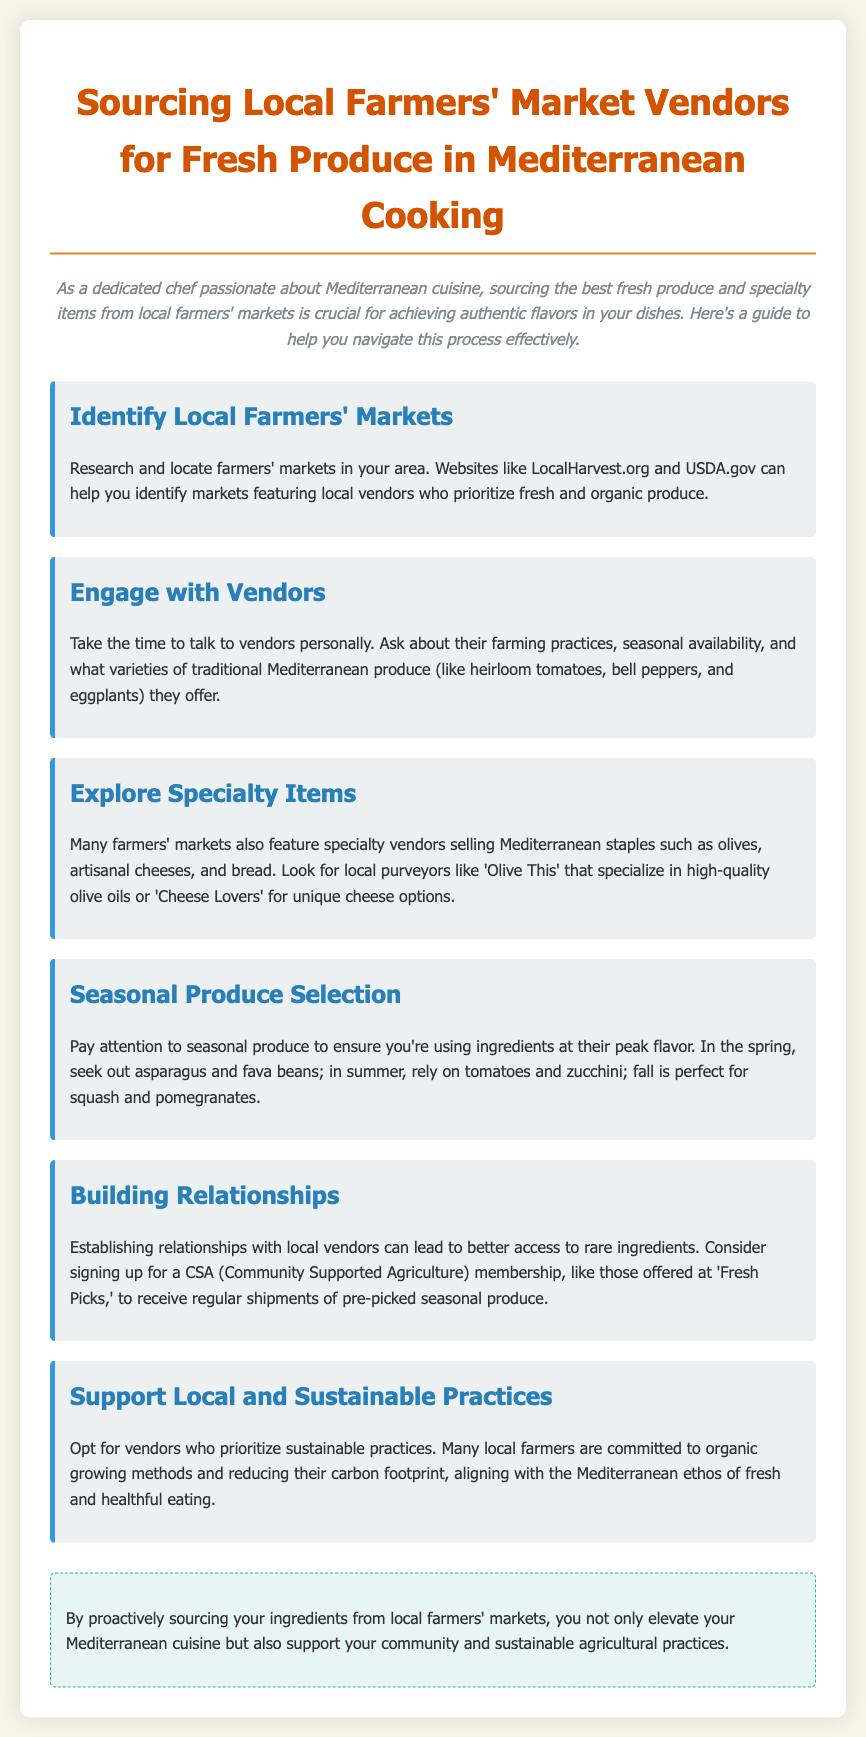What is the title of the document? The title of the document is stated at the top.
Answer: Sourcing Local Farmers' Market Vendors for Fresh Produce in Mediterranean Cooking What are two websites suggested for finding local farmers' markets? The document lists websites that can help find markets.
Answer: LocalHarvest.org and USDA.gov Which Mediterranean produce is mentioned as needing to be seasonal? The text highlights the importance of selecting produce according to the season.
Answer: Heirloom tomatoes What is a suggested item to explore at farmers' markets besides fresh produce? The document recommends looking for specialty items.
Answer: Artisanal cheeses What is a CSA? The document mentions a type of membership related to farmers' markets.
Answer: Community Supported Agriculture Why should chefs source ingredients from local vendors? The document explains multiple benefits of sourcing ingredients.
Answer: Support community and sustainable practices What should you pay attention to when sourcing seasonal produce? The document advises to focus on something specific during selection.
Answer: Peak flavor Which vendor is specifically mentioned for high-quality olive oils? The document provides an example of a vendor for a specific product.
Answer: Olive This What practice do many local farmers prioritize according to the document? The document discusses the importance of environmental responsibility in farming.
Answer: Sustainable practices 